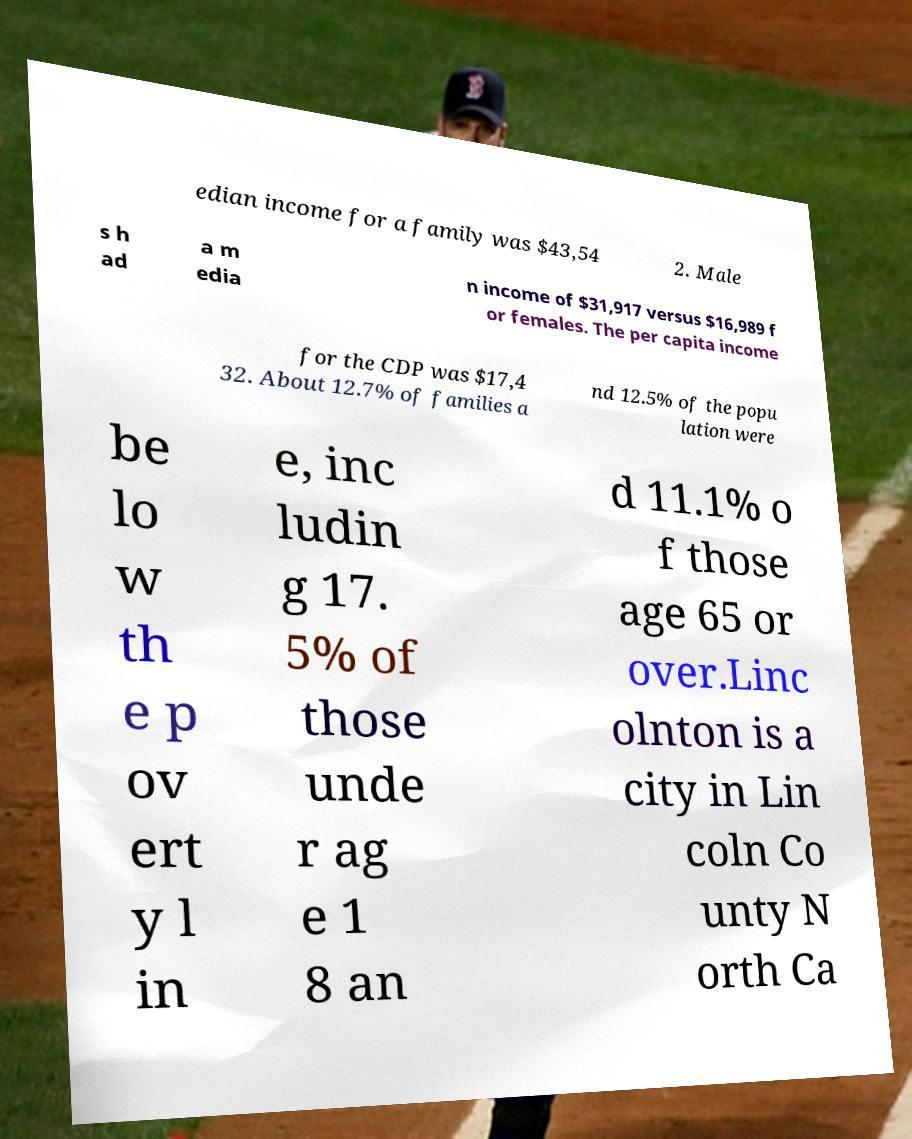What messages or text are displayed in this image? I need them in a readable, typed format. edian income for a family was $43,54 2. Male s h ad a m edia n income of $31,917 versus $16,989 f or females. The per capita income for the CDP was $17,4 32. About 12.7% of families a nd 12.5% of the popu lation were be lo w th e p ov ert y l in e, inc ludin g 17. 5% of those unde r ag e 1 8 an d 11.1% o f those age 65 or over.Linc olnton is a city in Lin coln Co unty N orth Ca 